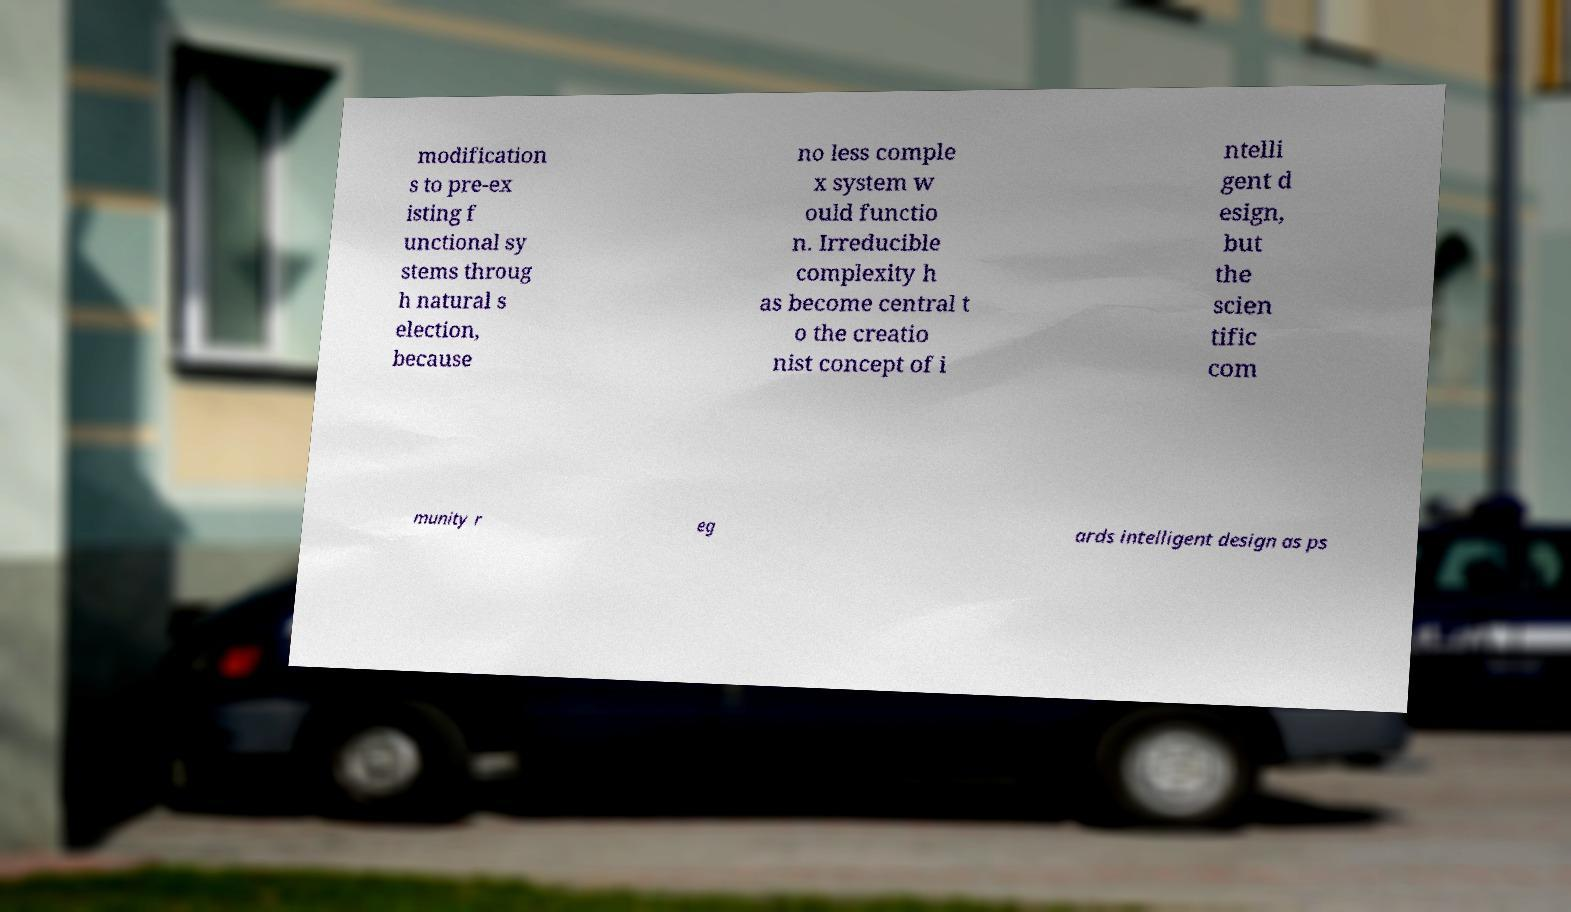For documentation purposes, I need the text within this image transcribed. Could you provide that? modification s to pre-ex isting f unctional sy stems throug h natural s election, because no less comple x system w ould functio n. Irreducible complexity h as become central t o the creatio nist concept of i ntelli gent d esign, but the scien tific com munity r eg ards intelligent design as ps 